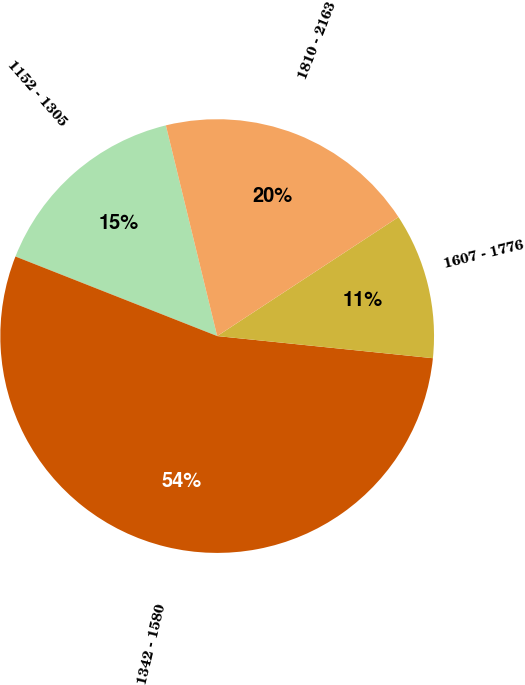Convert chart. <chart><loc_0><loc_0><loc_500><loc_500><pie_chart><fcel>1152 - 1305<fcel>1342 - 1580<fcel>1607 - 1776<fcel>1810 - 2163<nl><fcel>15.22%<fcel>54.35%<fcel>10.87%<fcel>19.56%<nl></chart> 